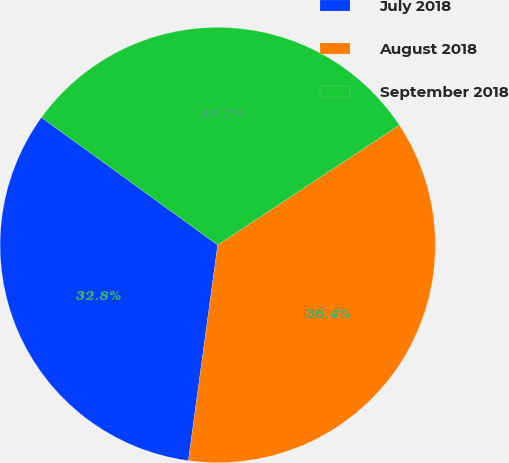Convert chart. <chart><loc_0><loc_0><loc_500><loc_500><pie_chart><fcel>July 2018<fcel>August 2018<fcel>September 2018<nl><fcel>32.82%<fcel>36.44%<fcel>30.74%<nl></chart> 